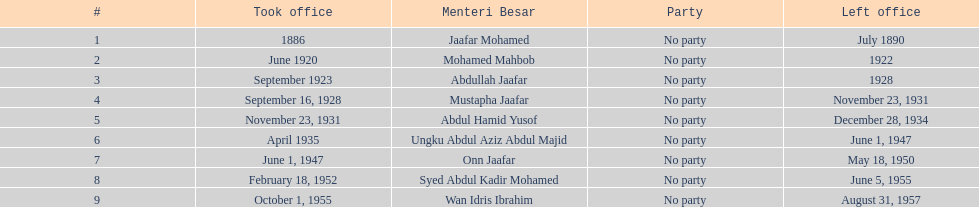Who were all of the menteri besars? Jaafar Mohamed, Mohamed Mahbob, Abdullah Jaafar, Mustapha Jaafar, Abdul Hamid Yusof, Ungku Abdul Aziz Abdul Majid, Onn Jaafar, Syed Abdul Kadir Mohamed, Wan Idris Ibrahim. When did they take office? 1886, June 1920, September 1923, September 16, 1928, November 23, 1931, April 1935, June 1, 1947, February 18, 1952, October 1, 1955. And when did they leave? July 1890, 1922, 1928, November 23, 1931, December 28, 1934, June 1, 1947, May 18, 1950, June 5, 1955, August 31, 1957. Now, who was in office for less than four years? Mohamed Mahbob. 